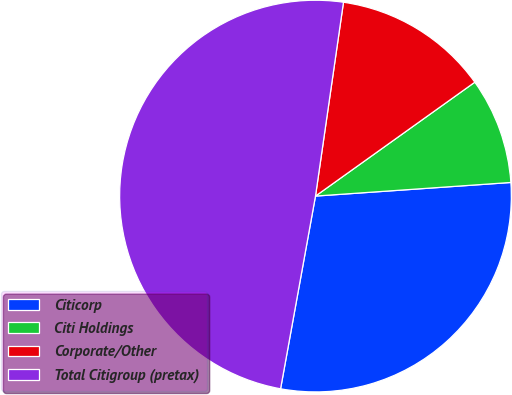Convert chart to OTSL. <chart><loc_0><loc_0><loc_500><loc_500><pie_chart><fcel>Citicorp<fcel>Citi Holdings<fcel>Corporate/Other<fcel>Total Citigroup (pretax)<nl><fcel>28.96%<fcel>8.77%<fcel>12.84%<fcel>49.43%<nl></chart> 